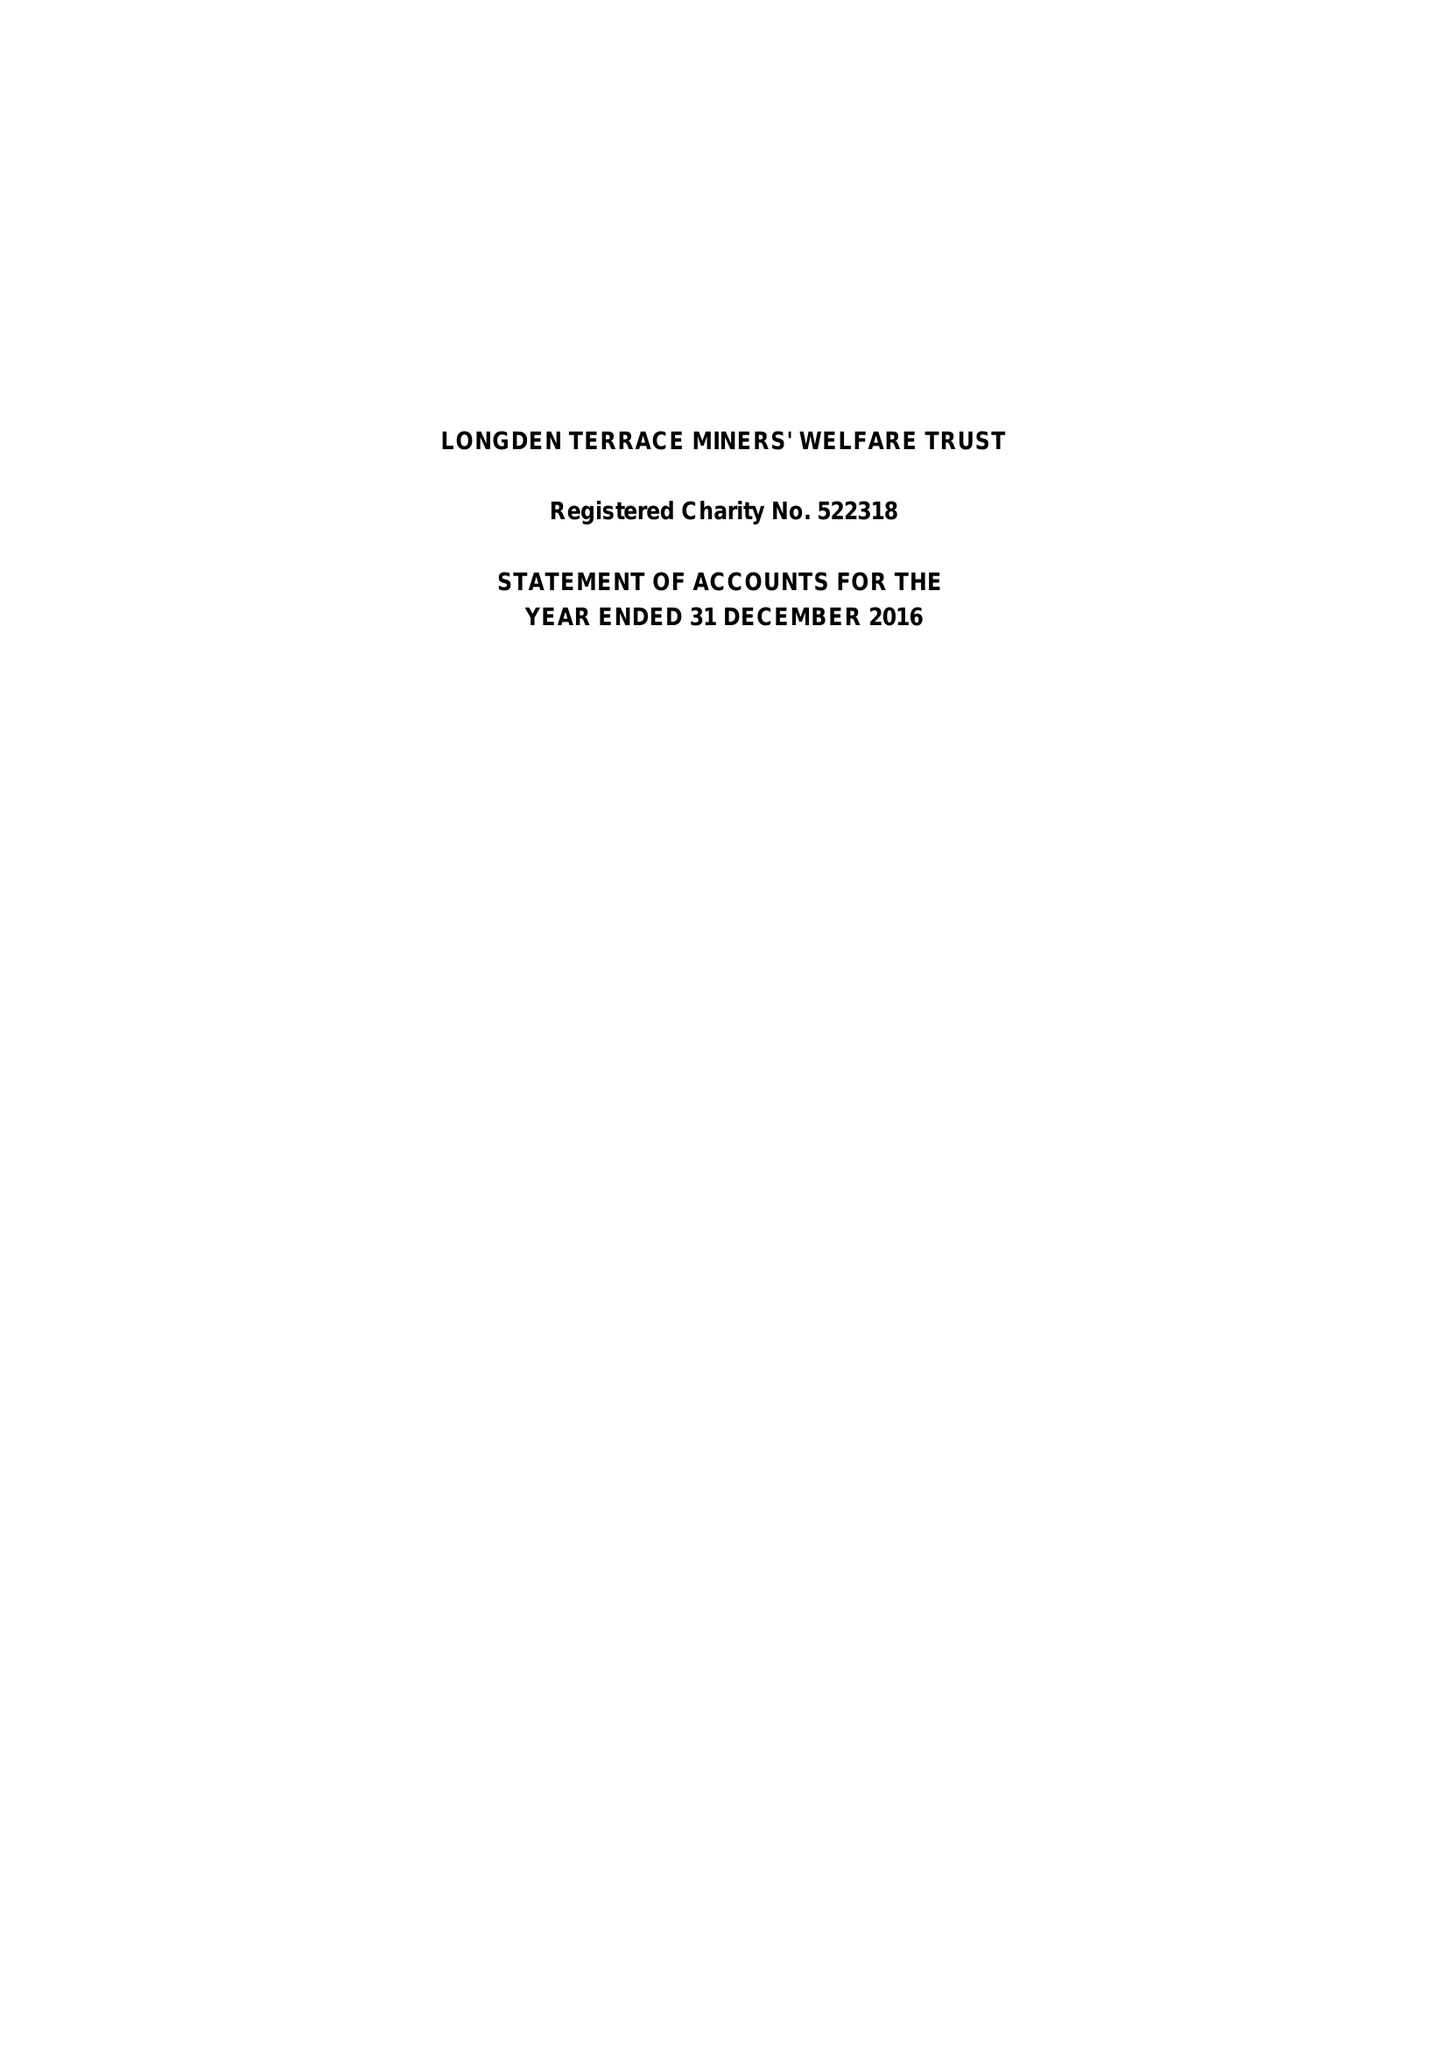What is the value for the charity_number?
Answer the question using a single word or phrase. 522318 